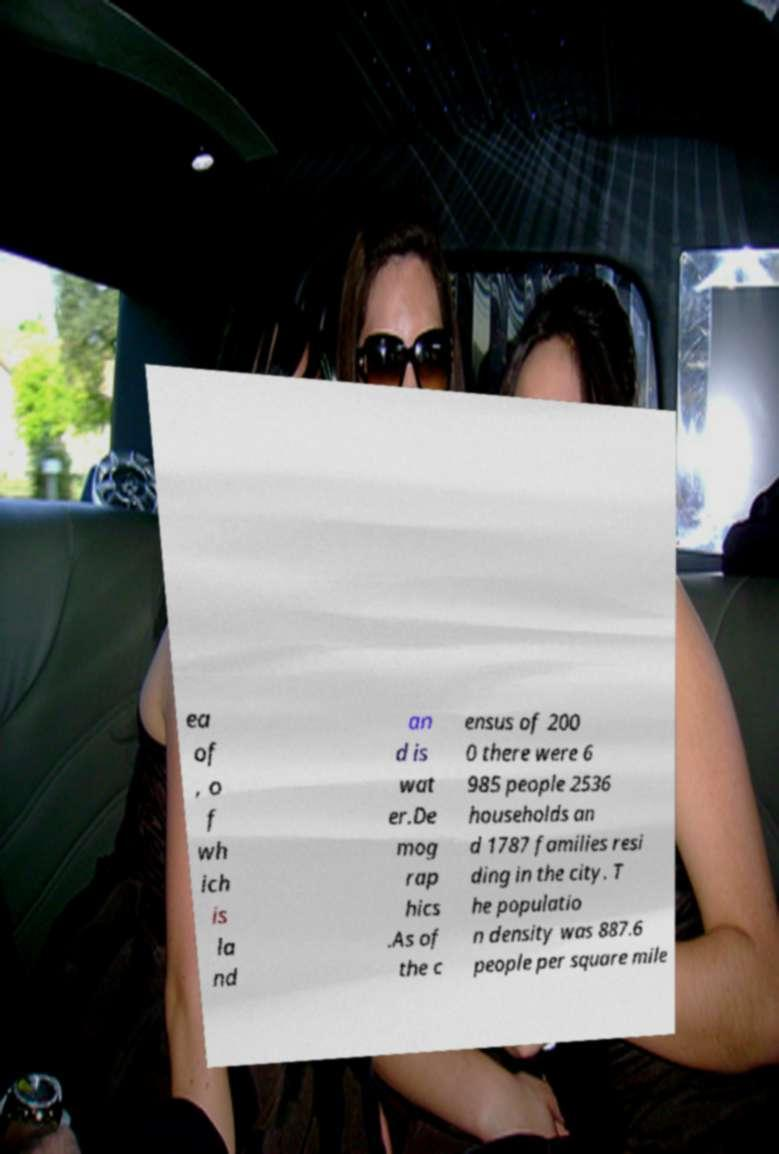Please read and relay the text visible in this image. What does it say? ea of , o f wh ich is la nd an d is wat er.De mog rap hics .As of the c ensus of 200 0 there were 6 985 people 2536 households an d 1787 families resi ding in the city. T he populatio n density was 887.6 people per square mile 